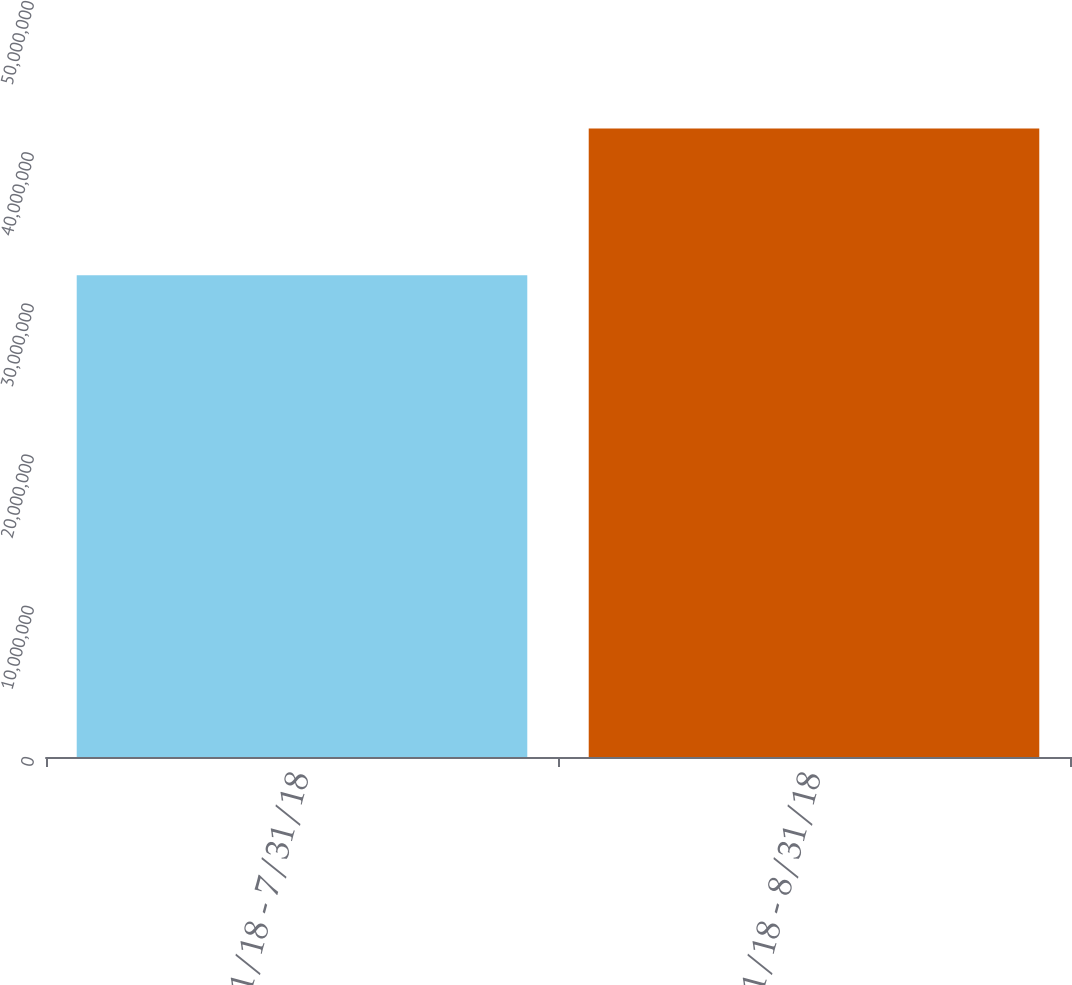Convert chart. <chart><loc_0><loc_0><loc_500><loc_500><bar_chart><fcel>7/1/18 - 7/31/18<fcel>8/1/18 - 8/31/18<nl><fcel>3.18554e+07<fcel>4.15696e+07<nl></chart> 